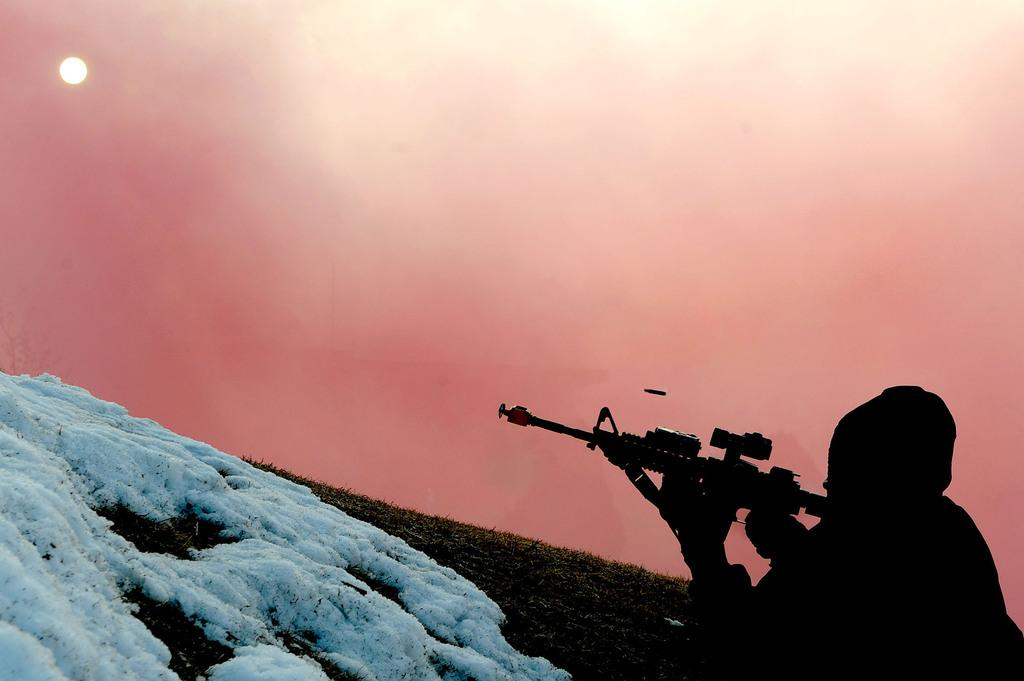What type of terrain is visible in the image? There is ground visible in the image, and it is covered in snow. What is the person in the image doing? The person is lying on the ground and holding a weapon. What can be seen in the sky in the background of the image? The sky is visible in the background of the image, and the moon is also visible. What type of beef is being served at the surprise party in the image? There is no surprise party or beef present in the image. 